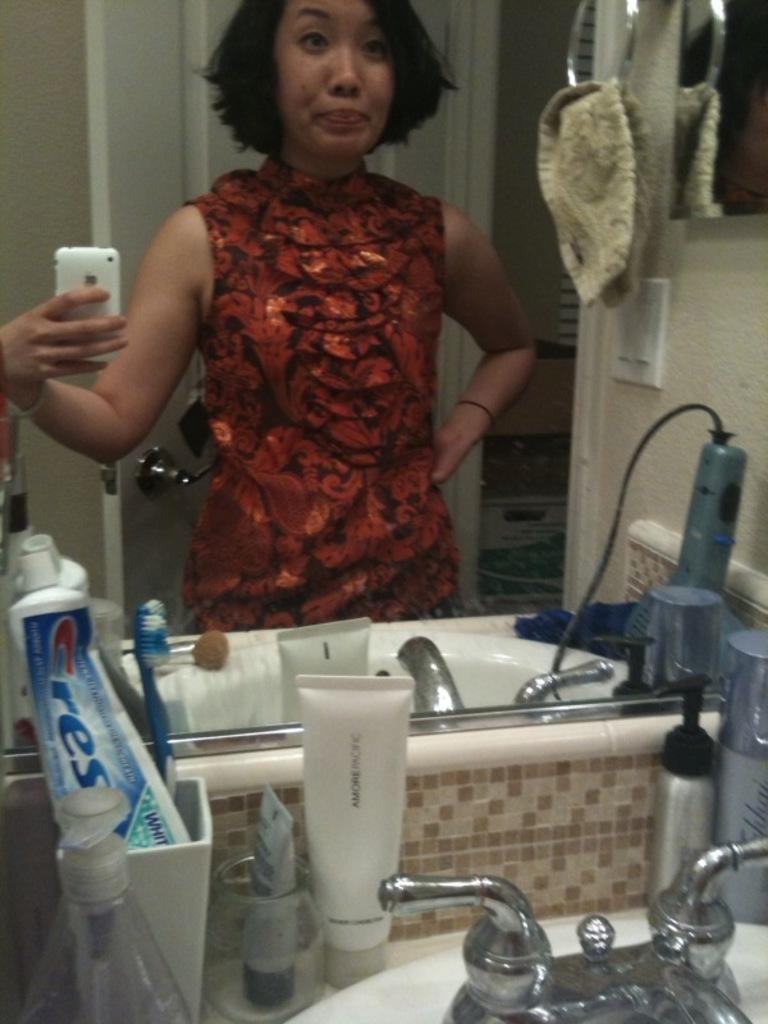<image>
Create a compact narrative representing the image presented. a lady is taking a selfie in the bathroom woth Crest on the counter 